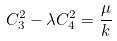<formula> <loc_0><loc_0><loc_500><loc_500>C _ { 3 } ^ { 2 } - \lambda C _ { 4 } ^ { 2 } = \frac { \mu } { k }</formula> 